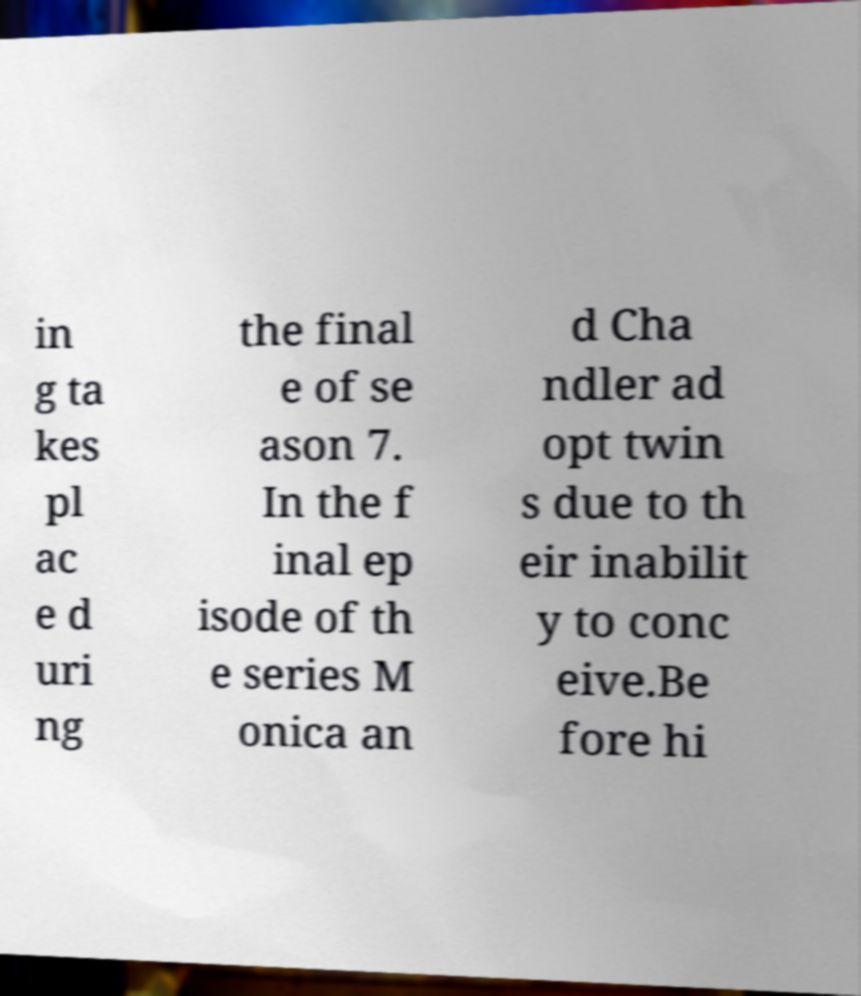Could you assist in decoding the text presented in this image and type it out clearly? in g ta kes pl ac e d uri ng the final e of se ason 7. In the f inal ep isode of th e series M onica an d Cha ndler ad opt twin s due to th eir inabilit y to conc eive.Be fore hi 